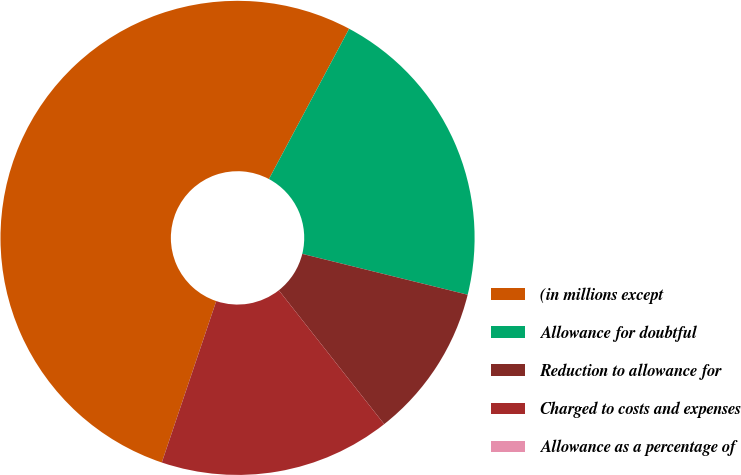<chart> <loc_0><loc_0><loc_500><loc_500><pie_chart><fcel>(in millions except<fcel>Allowance for doubtful<fcel>Reduction to allowance for<fcel>Charged to costs and expenses<fcel>Allowance as a percentage of<nl><fcel>52.62%<fcel>21.05%<fcel>10.53%<fcel>15.79%<fcel>0.0%<nl></chart> 